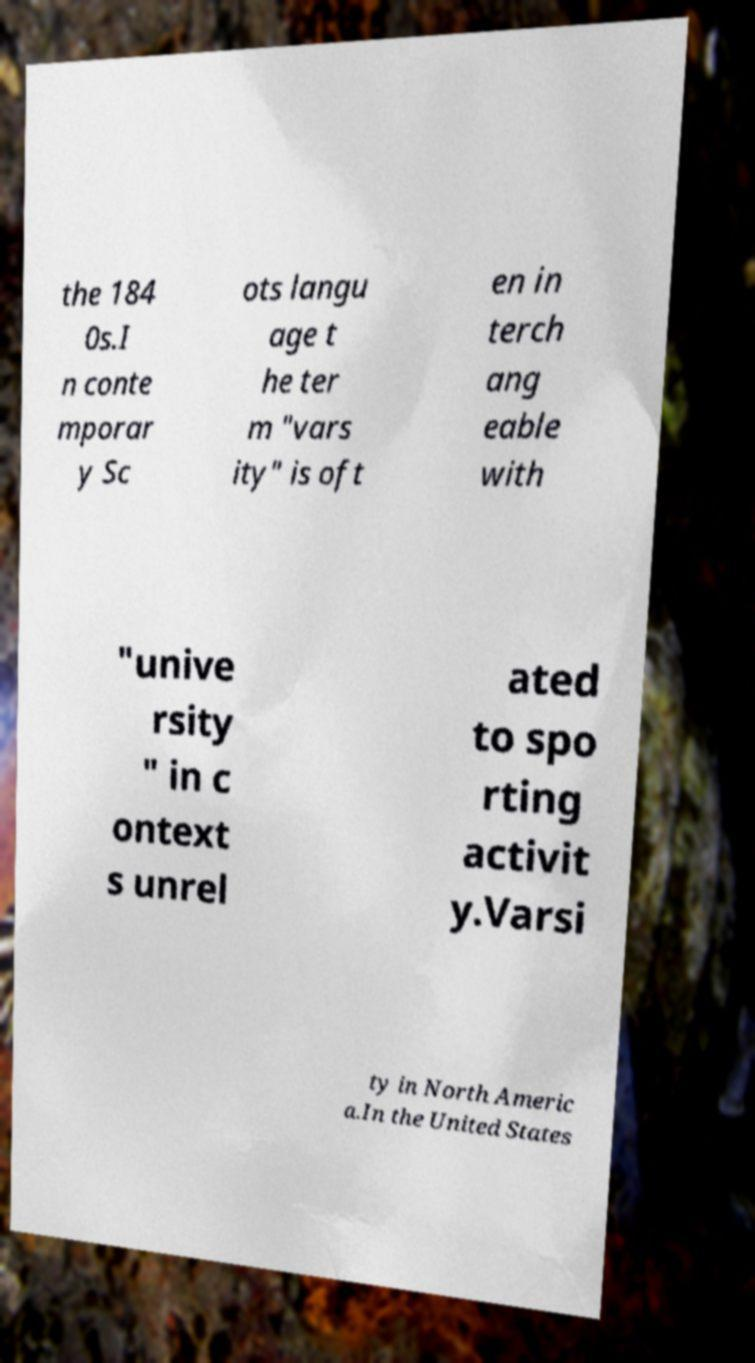Can you accurately transcribe the text from the provided image for me? the 184 0s.I n conte mporar y Sc ots langu age t he ter m "vars ity" is oft en in terch ang eable with "unive rsity " in c ontext s unrel ated to spo rting activit y.Varsi ty in North Americ a.In the United States 